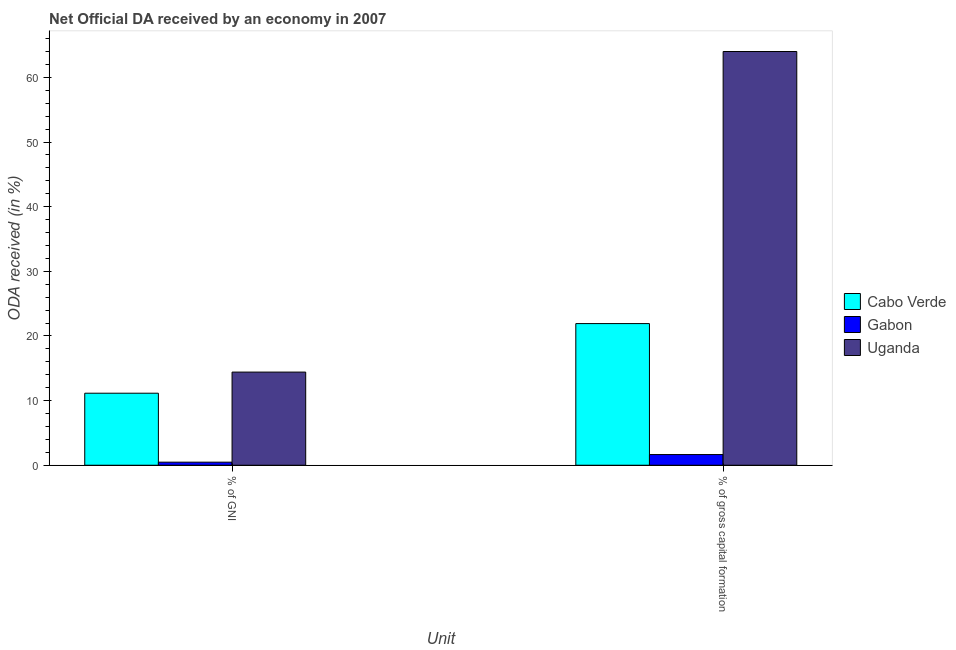Are the number of bars per tick equal to the number of legend labels?
Make the answer very short. Yes. How many bars are there on the 2nd tick from the right?
Give a very brief answer. 3. What is the label of the 2nd group of bars from the left?
Make the answer very short. % of gross capital formation. What is the oda received as percentage of gross capital formation in Gabon?
Your answer should be compact. 1.65. Across all countries, what is the maximum oda received as percentage of gross capital formation?
Offer a very short reply. 64. Across all countries, what is the minimum oda received as percentage of gross capital formation?
Your answer should be very brief. 1.65. In which country was the oda received as percentage of gross capital formation maximum?
Make the answer very short. Uganda. In which country was the oda received as percentage of gni minimum?
Ensure brevity in your answer.  Gabon. What is the total oda received as percentage of gross capital formation in the graph?
Keep it short and to the point. 87.56. What is the difference between the oda received as percentage of gni in Uganda and that in Cabo Verde?
Offer a very short reply. 3.27. What is the difference between the oda received as percentage of gross capital formation in Uganda and the oda received as percentage of gni in Gabon?
Provide a short and direct response. 63.52. What is the average oda received as percentage of gross capital formation per country?
Make the answer very short. 29.19. What is the difference between the oda received as percentage of gross capital formation and oda received as percentage of gni in Cabo Verde?
Make the answer very short. 10.77. In how many countries, is the oda received as percentage of gross capital formation greater than 46 %?
Provide a succinct answer. 1. What is the ratio of the oda received as percentage of gni in Uganda to that in Cabo Verde?
Offer a terse response. 1.29. Is the oda received as percentage of gross capital formation in Uganda less than that in Gabon?
Provide a succinct answer. No. What does the 1st bar from the left in % of GNI represents?
Offer a very short reply. Cabo Verde. What does the 3rd bar from the right in % of gross capital formation represents?
Give a very brief answer. Cabo Verde. Are all the bars in the graph horizontal?
Your answer should be compact. No. How many countries are there in the graph?
Give a very brief answer. 3. What is the difference between two consecutive major ticks on the Y-axis?
Your answer should be very brief. 10. Are the values on the major ticks of Y-axis written in scientific E-notation?
Offer a very short reply. No. Where does the legend appear in the graph?
Provide a succinct answer. Center right. How many legend labels are there?
Give a very brief answer. 3. How are the legend labels stacked?
Your answer should be compact. Vertical. What is the title of the graph?
Provide a short and direct response. Net Official DA received by an economy in 2007. What is the label or title of the X-axis?
Your response must be concise. Unit. What is the label or title of the Y-axis?
Make the answer very short. ODA received (in %). What is the ODA received (in %) in Cabo Verde in % of GNI?
Your response must be concise. 11.14. What is the ODA received (in %) in Gabon in % of GNI?
Offer a very short reply. 0.47. What is the ODA received (in %) in Uganda in % of GNI?
Keep it short and to the point. 14.41. What is the ODA received (in %) of Cabo Verde in % of gross capital formation?
Your response must be concise. 21.91. What is the ODA received (in %) in Gabon in % of gross capital formation?
Give a very brief answer. 1.65. What is the ODA received (in %) in Uganda in % of gross capital formation?
Your answer should be compact. 64. Across all Unit, what is the maximum ODA received (in %) in Cabo Verde?
Your answer should be compact. 21.91. Across all Unit, what is the maximum ODA received (in %) in Gabon?
Ensure brevity in your answer.  1.65. Across all Unit, what is the maximum ODA received (in %) in Uganda?
Ensure brevity in your answer.  64. Across all Unit, what is the minimum ODA received (in %) in Cabo Verde?
Offer a terse response. 11.14. Across all Unit, what is the minimum ODA received (in %) in Gabon?
Offer a terse response. 0.47. Across all Unit, what is the minimum ODA received (in %) of Uganda?
Offer a very short reply. 14.41. What is the total ODA received (in %) in Cabo Verde in the graph?
Keep it short and to the point. 33.05. What is the total ODA received (in %) of Gabon in the graph?
Offer a very short reply. 2.13. What is the total ODA received (in %) in Uganda in the graph?
Your answer should be compact. 78.41. What is the difference between the ODA received (in %) of Cabo Verde in % of GNI and that in % of gross capital formation?
Provide a succinct answer. -10.77. What is the difference between the ODA received (in %) in Gabon in % of GNI and that in % of gross capital formation?
Offer a very short reply. -1.18. What is the difference between the ODA received (in %) in Uganda in % of GNI and that in % of gross capital formation?
Your answer should be compact. -49.59. What is the difference between the ODA received (in %) of Cabo Verde in % of GNI and the ODA received (in %) of Gabon in % of gross capital formation?
Offer a terse response. 9.49. What is the difference between the ODA received (in %) of Cabo Verde in % of GNI and the ODA received (in %) of Uganda in % of gross capital formation?
Provide a succinct answer. -52.86. What is the difference between the ODA received (in %) in Gabon in % of GNI and the ODA received (in %) in Uganda in % of gross capital formation?
Keep it short and to the point. -63.52. What is the average ODA received (in %) in Cabo Verde per Unit?
Your answer should be compact. 16.53. What is the average ODA received (in %) in Gabon per Unit?
Make the answer very short. 1.06. What is the average ODA received (in %) of Uganda per Unit?
Provide a short and direct response. 39.2. What is the difference between the ODA received (in %) in Cabo Verde and ODA received (in %) in Gabon in % of GNI?
Your answer should be compact. 10.67. What is the difference between the ODA received (in %) of Cabo Verde and ODA received (in %) of Uganda in % of GNI?
Your response must be concise. -3.27. What is the difference between the ODA received (in %) in Gabon and ODA received (in %) in Uganda in % of GNI?
Give a very brief answer. -13.93. What is the difference between the ODA received (in %) of Cabo Verde and ODA received (in %) of Gabon in % of gross capital formation?
Your response must be concise. 20.26. What is the difference between the ODA received (in %) in Cabo Verde and ODA received (in %) in Uganda in % of gross capital formation?
Provide a succinct answer. -42.09. What is the difference between the ODA received (in %) of Gabon and ODA received (in %) of Uganda in % of gross capital formation?
Your answer should be compact. -62.35. What is the ratio of the ODA received (in %) in Cabo Verde in % of GNI to that in % of gross capital formation?
Offer a very short reply. 0.51. What is the ratio of the ODA received (in %) of Gabon in % of GNI to that in % of gross capital formation?
Keep it short and to the point. 0.29. What is the ratio of the ODA received (in %) in Uganda in % of GNI to that in % of gross capital formation?
Keep it short and to the point. 0.23. What is the difference between the highest and the second highest ODA received (in %) in Cabo Verde?
Provide a succinct answer. 10.77. What is the difference between the highest and the second highest ODA received (in %) of Gabon?
Provide a succinct answer. 1.18. What is the difference between the highest and the second highest ODA received (in %) in Uganda?
Ensure brevity in your answer.  49.59. What is the difference between the highest and the lowest ODA received (in %) of Cabo Verde?
Your answer should be very brief. 10.77. What is the difference between the highest and the lowest ODA received (in %) in Gabon?
Your response must be concise. 1.18. What is the difference between the highest and the lowest ODA received (in %) of Uganda?
Your answer should be very brief. 49.59. 